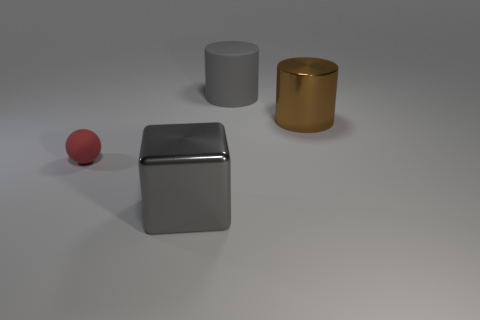Do the big cube and the gray thing behind the tiny thing have the same material?
Keep it short and to the point. No. There is a object that is the same color as the matte cylinder; what is its material?
Make the answer very short. Metal. There is a gray object that is left of the cylinder behind the brown thing; what is its material?
Make the answer very short. Metal. There is a brown object that is the same size as the cube; what is its material?
Your answer should be compact. Metal. How many other objects are the same color as the tiny object?
Offer a very short reply. 0. What is the material of the object that is both to the left of the brown metallic thing and behind the red object?
Offer a terse response. Rubber. The shiny cube has what color?
Keep it short and to the point. Gray. There is a gray object that is behind the tiny red rubber sphere; what shape is it?
Give a very brief answer. Cylinder. Are there any tiny red balls in front of the rubber object that is on the right side of the shiny object on the left side of the big matte object?
Provide a succinct answer. Yes. Is there anything else that is the same shape as the red object?
Offer a very short reply. No. 